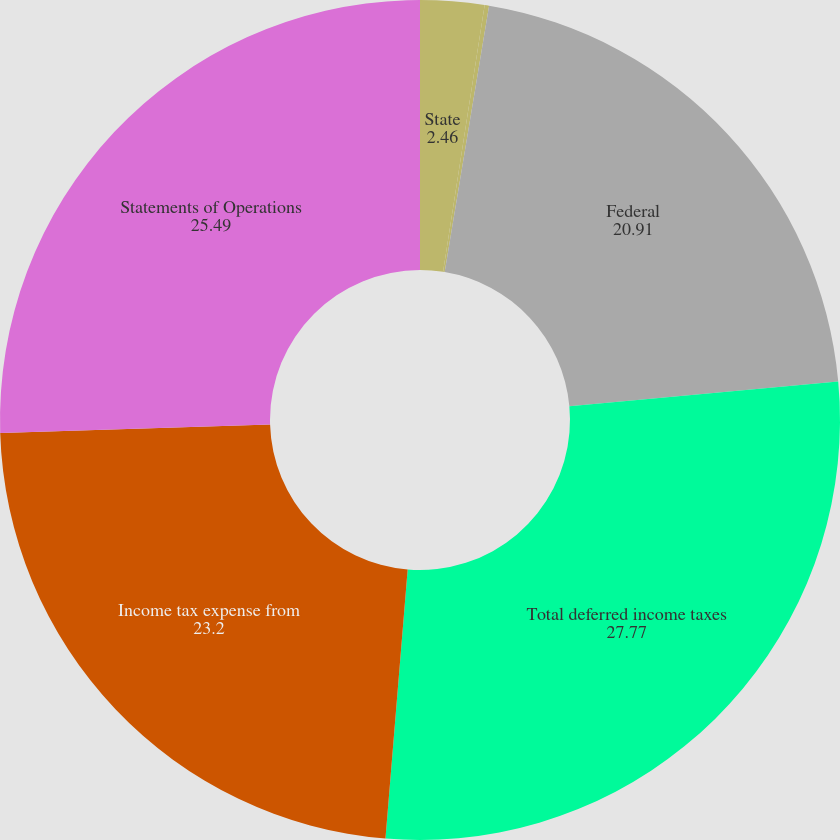<chart> <loc_0><loc_0><loc_500><loc_500><pie_chart><fcel>State<fcel>Total current income taxes<fcel>Federal<fcel>Total deferred income taxes<fcel>Income tax expense from<fcel>Statements of Operations<nl><fcel>2.46%<fcel>0.17%<fcel>20.91%<fcel>27.77%<fcel>23.2%<fcel>25.49%<nl></chart> 